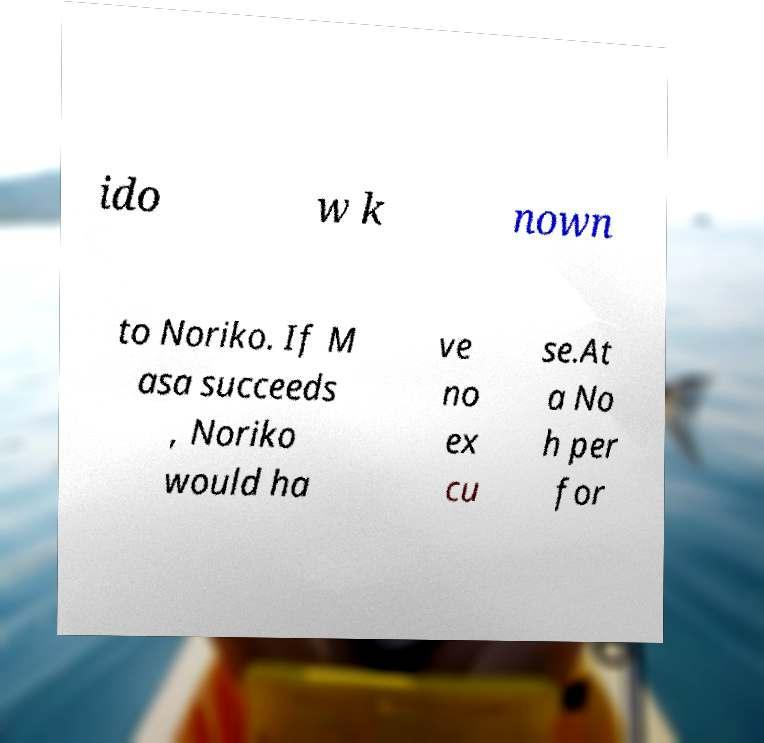There's text embedded in this image that I need extracted. Can you transcribe it verbatim? ido w k nown to Noriko. If M asa succeeds , Noriko would ha ve no ex cu se.At a No h per for 